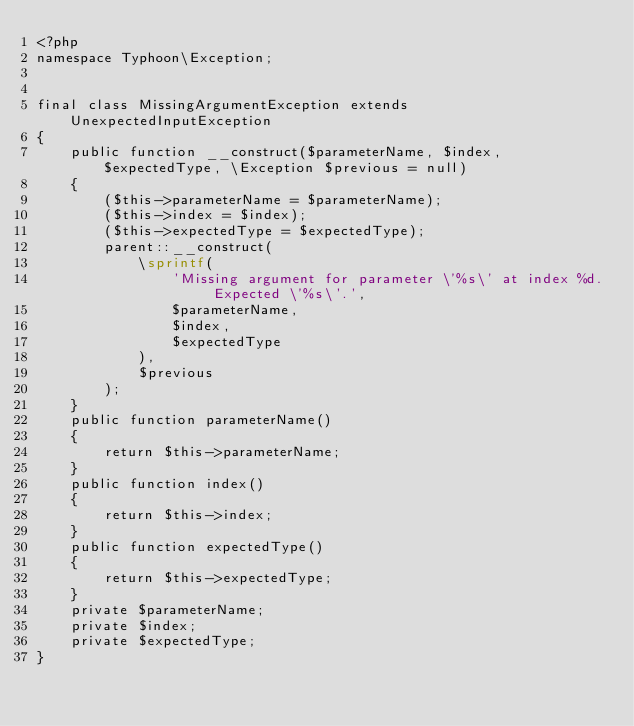<code> <loc_0><loc_0><loc_500><loc_500><_PHP_><?php
namespace Typhoon\Exception;


final class MissingArgumentException extends UnexpectedInputException
{
    public function __construct($parameterName, $index, $expectedType, \Exception $previous = null)
    {
        ($this->parameterName = $parameterName);
        ($this->index = $index);
        ($this->expectedType = $expectedType);
        parent::__construct(
            \sprintf(
                'Missing argument for parameter \'%s\' at index %d. Expected \'%s\'.',
                $parameterName,
                $index,
                $expectedType
            ),
            $previous
        );
    }
    public function parameterName()
    {
        return $this->parameterName;
    }
    public function index()
    {
        return $this->index;
    }
    public function expectedType()
    {
        return $this->expectedType;
    }
    private $parameterName;
    private $index;
    private $expectedType;
}
</code> 